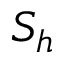<formula> <loc_0><loc_0><loc_500><loc_500>S _ { h }</formula> 